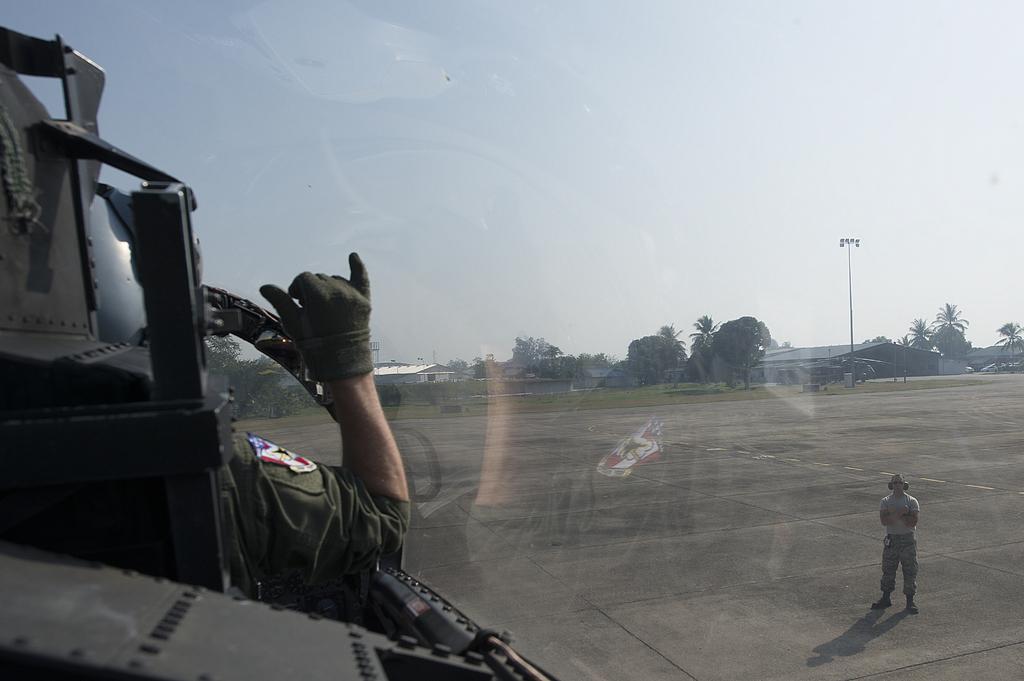Describe this image in one or two sentences. In this picture I can observe a person standing on the runway on the right side. On the left side I can observe a person. In the background there are trees and sky. 